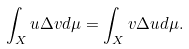Convert formula to latex. <formula><loc_0><loc_0><loc_500><loc_500>\int _ { X } u \Delta v d \mu = \int _ { X } v \Delta u d \mu .</formula> 